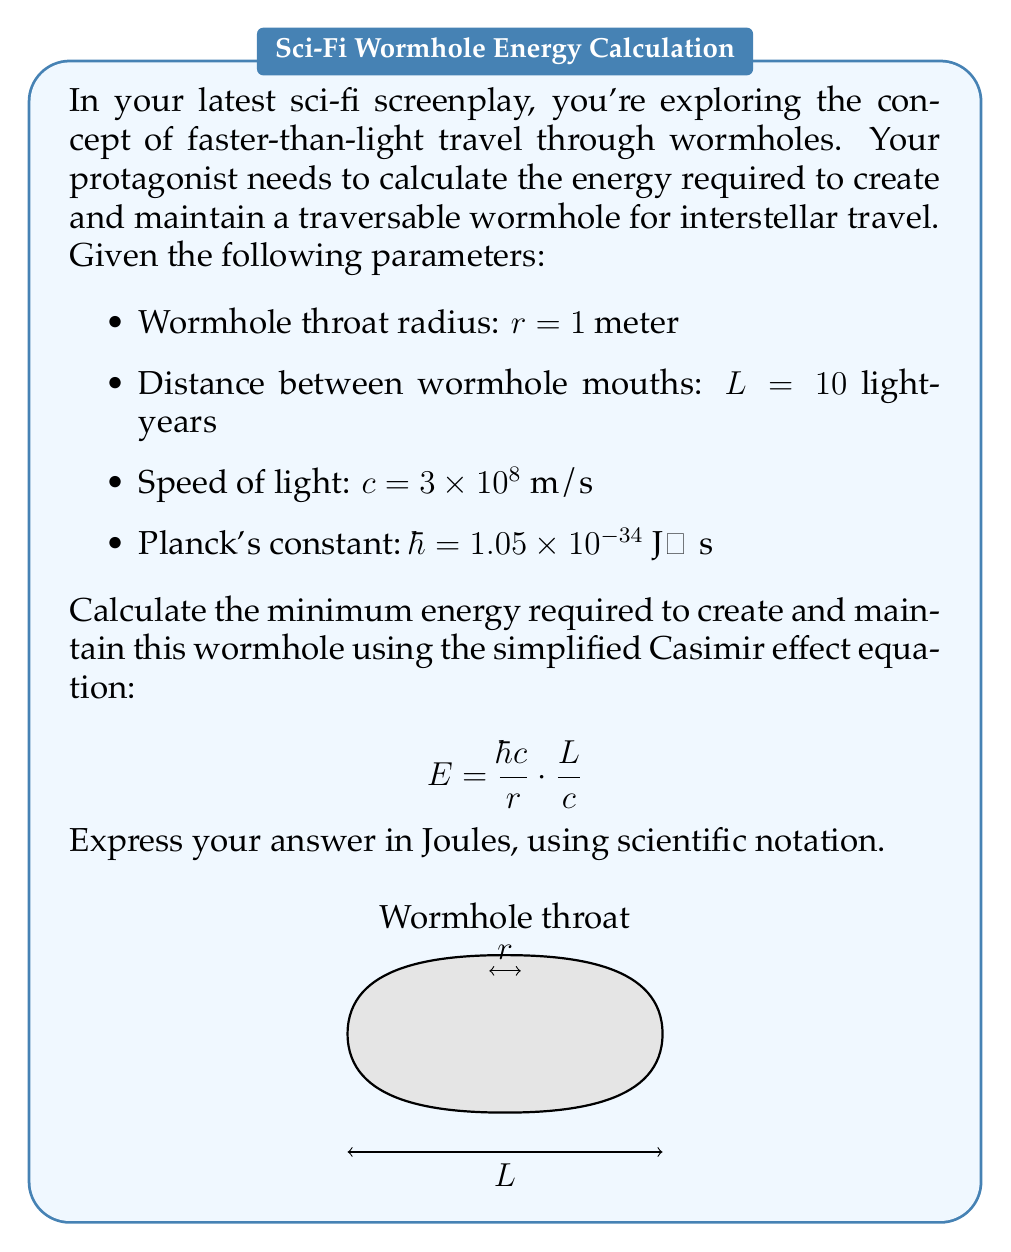Teach me how to tackle this problem. To solve this problem, we'll use the given equation and substitute the known values:

$$E = \frac{\hbar c}{r} \cdot \frac{L}{c}$$

1. First, let's convert the distance L from light-years to meters:
   $L = 10 \text{ light-years} = 10 \times (9.461 \times 10^{15} \text{ m}) = 9.461 \times 10^{16} \text{ m}$

2. Now, let's substitute all the values into the equation:
   $E = \frac{(1.05 \times 10^{-34} \text{ J⋅s}) \times (3 \times 10^8 \text{ m/s})}{1 \text{ m}} \cdot \frac{9.461 \times 10^{16} \text{ m}}{3 \times 10^8 \text{ m/s}}$

3. Simplify:
   $E = (3.15 \times 10^{-26} \text{ J}) \times (3.1537 \times 10^8)$

4. Calculate the final result:
   $E = 9.934 \times 10^{-18} \text{ J}$

5. Round to three significant figures:
   $E \approx 9.93 \times 10^{-18} \text{ J}$

This extremely small energy requirement is due to the simplified nature of the equation and doesn't account for many other factors that would likely increase the energy needed in a more realistic scenario.
Answer: $9.93 \times 10^{-18}$ J 